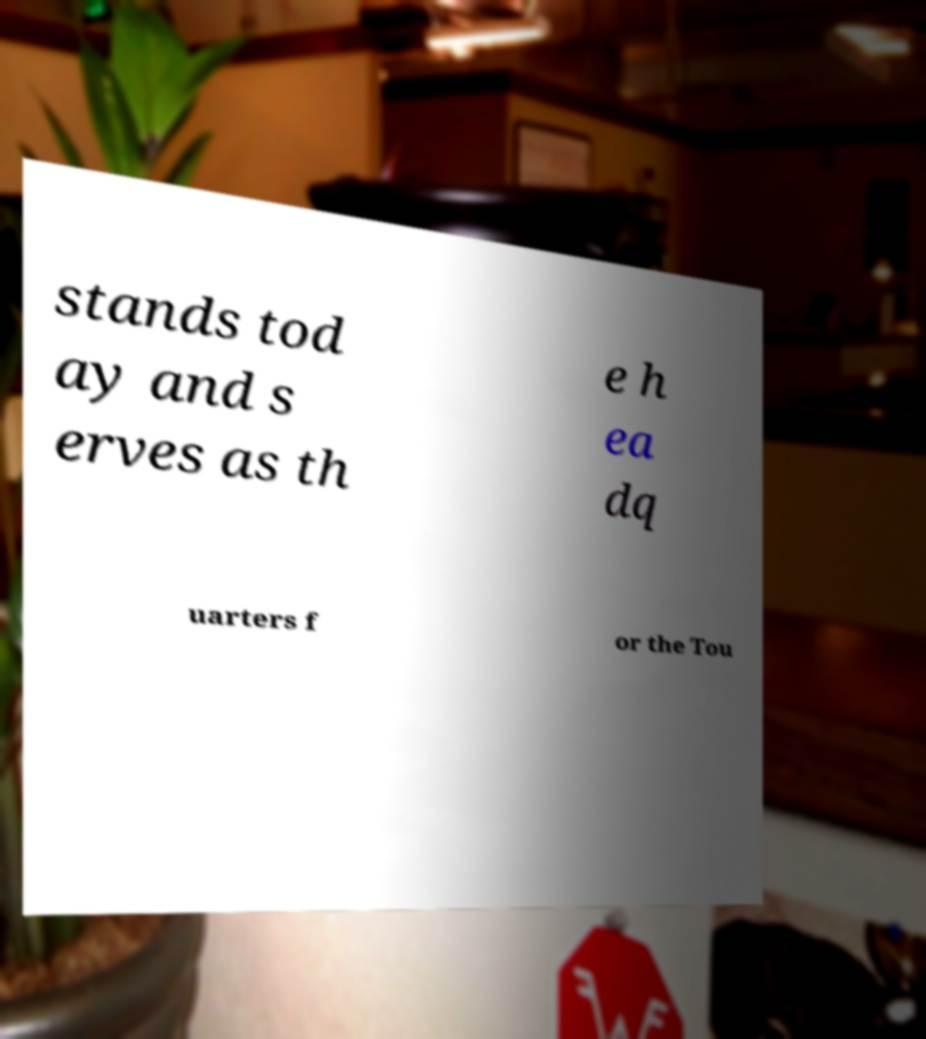Can you accurately transcribe the text from the provided image for me? stands tod ay and s erves as th e h ea dq uarters f or the Tou 